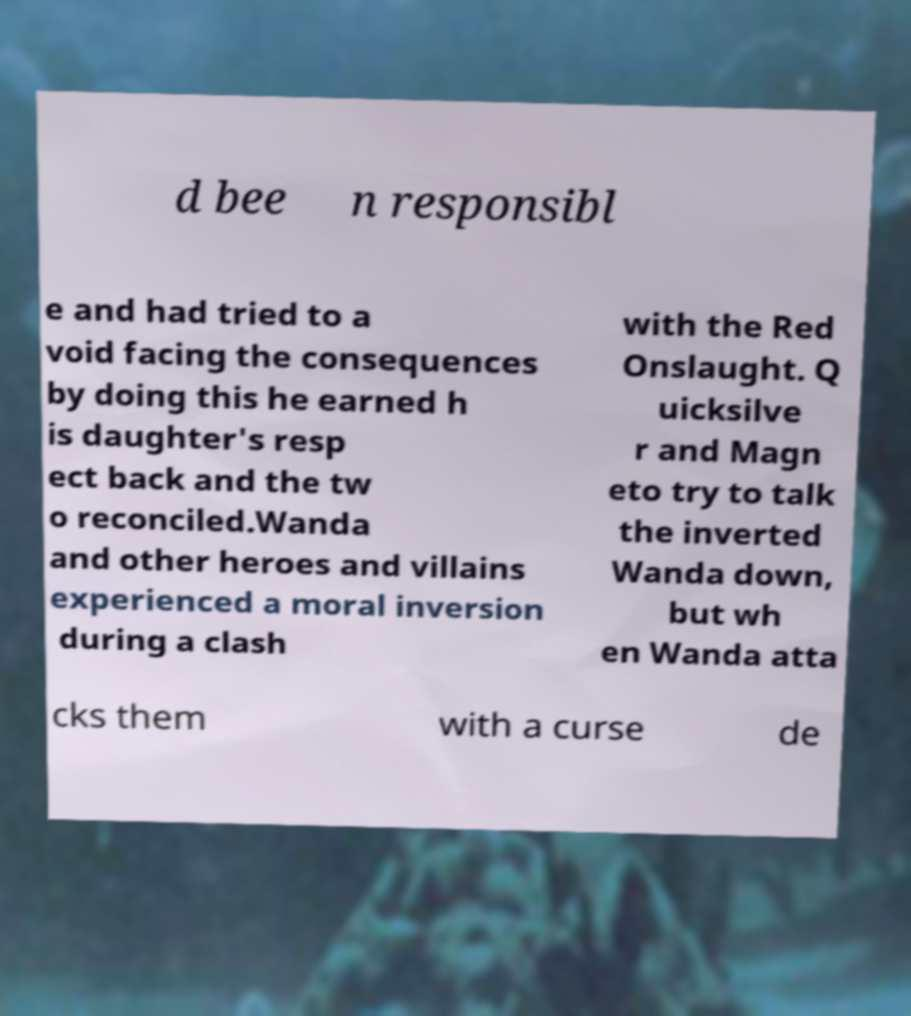I need the written content from this picture converted into text. Can you do that? d bee n responsibl e and had tried to a void facing the consequences by doing this he earned h is daughter's resp ect back and the tw o reconciled.Wanda and other heroes and villains experienced a moral inversion during a clash with the Red Onslaught. Q uicksilve r and Magn eto try to talk the inverted Wanda down, but wh en Wanda atta cks them with a curse de 